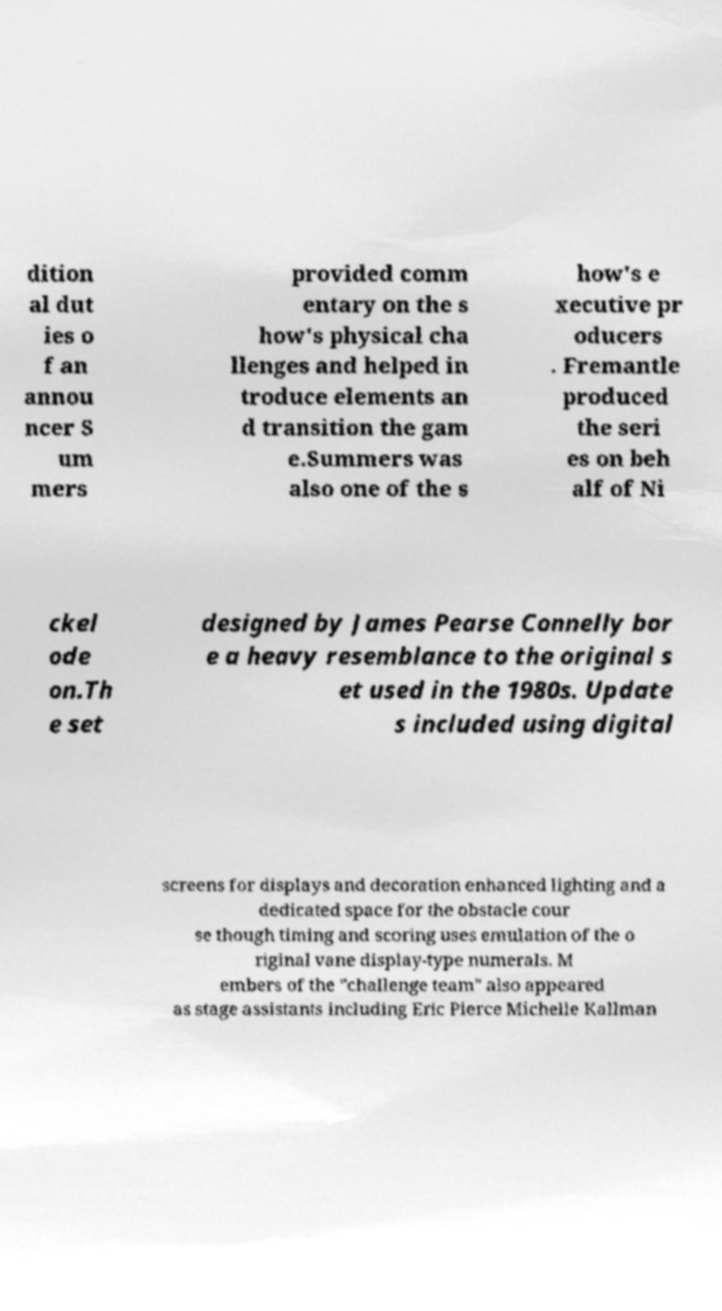For documentation purposes, I need the text within this image transcribed. Could you provide that? dition al dut ies o f an annou ncer S um mers provided comm entary on the s how's physical cha llenges and helped in troduce elements an d transition the gam e.Summers was also one of the s how's e xecutive pr oducers . Fremantle produced the seri es on beh alf of Ni ckel ode on.Th e set designed by James Pearse Connelly bor e a heavy resemblance to the original s et used in the 1980s. Update s included using digital screens for displays and decoration enhanced lighting and a dedicated space for the obstacle cour se though timing and scoring uses emulation of the o riginal vane display-type numerals. M embers of the "challenge team" also appeared as stage assistants including Eric Pierce Michelle Kallman 